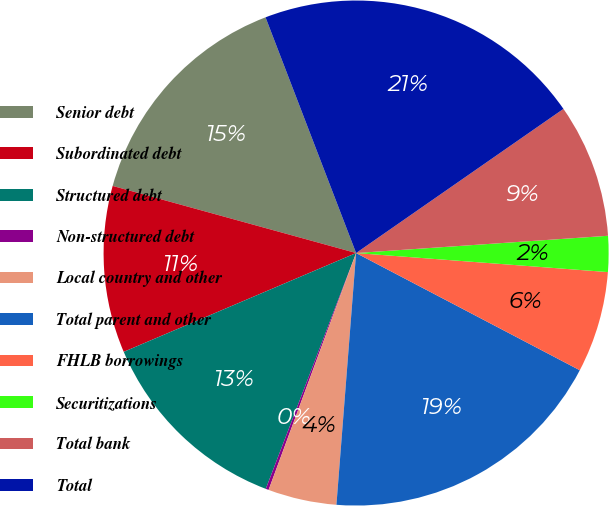Convert chart. <chart><loc_0><loc_0><loc_500><loc_500><pie_chart><fcel>Senior debt<fcel>Subordinated debt<fcel>Structured debt<fcel>Non-structured debt<fcel>Local country and other<fcel>Total parent and other<fcel>FHLB borrowings<fcel>Securitizations<fcel>Total bank<fcel>Total<nl><fcel>14.88%<fcel>10.68%<fcel>12.78%<fcel>0.19%<fcel>4.39%<fcel>18.56%<fcel>6.48%<fcel>2.29%<fcel>8.58%<fcel>21.17%<nl></chart> 